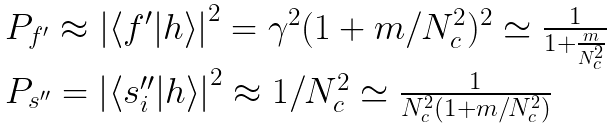<formula> <loc_0><loc_0><loc_500><loc_500>\begin{array} { l } P _ { f ^ { \prime } } \approx \left | \left \langle f ^ { \prime } | h \right \rangle \right | ^ { 2 } = \gamma ^ { 2 } ( 1 + m / N _ { c } ^ { 2 } ) ^ { 2 } \simeq \frac { 1 } { 1 + \frac { m } { N _ { c } ^ { 2 } } } \\ P _ { s ^ { \prime \prime } } = \left | \left \langle s _ { i } ^ { \prime \prime } | h \right \rangle \right | ^ { 2 } \approx 1 / N _ { c } ^ { 2 } \simeq \frac { 1 } { N _ { c } ^ { 2 } ( 1 + m / N _ { c } ^ { 2 } ) } \end{array}</formula> 